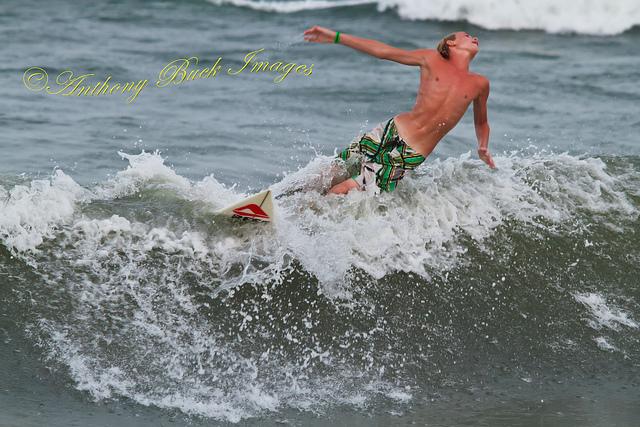What is the boy doing?
Answer briefly. Surfing. What color are the man's shorts?
Quick response, please. Green. Who is sponsoring the man's trousers?
Quick response, please. Billabong. Is the person wearing a wetsuit?
Write a very short answer. No. What color is the water?
Give a very brief answer. Blue. What is the boy standing on?
Answer briefly. Surfboard. What color are the boy's trunks?
Give a very brief answer. Green and white. 